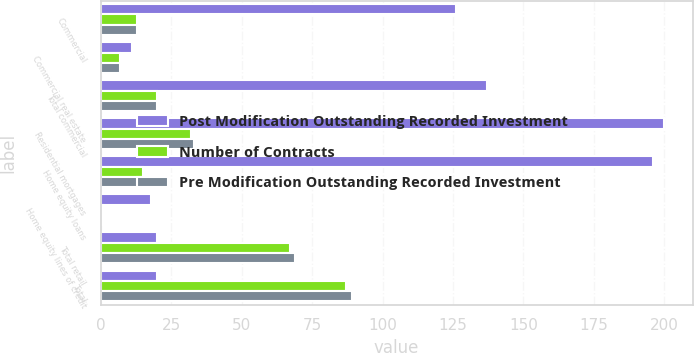Convert chart. <chart><loc_0><loc_0><loc_500><loc_500><stacked_bar_chart><ecel><fcel>Commercial<fcel>Commercial real estate<fcel>Total commercial<fcel>Residential mortgages<fcel>Home equity loans<fcel>Home equity lines of credit<fcel>Total retail<fcel>Total<nl><fcel>Post Modification Outstanding Recorded Investment<fcel>126<fcel>11<fcel>137<fcel>200<fcel>196<fcel>18<fcel>20<fcel>20<nl><fcel>Number of Contracts<fcel>13<fcel>7<fcel>20<fcel>32<fcel>15<fcel>1<fcel>67<fcel>87<nl><fcel>Pre Modification Outstanding Recorded Investment<fcel>13<fcel>7<fcel>20<fcel>33<fcel>16<fcel>1<fcel>69<fcel>89<nl></chart> 